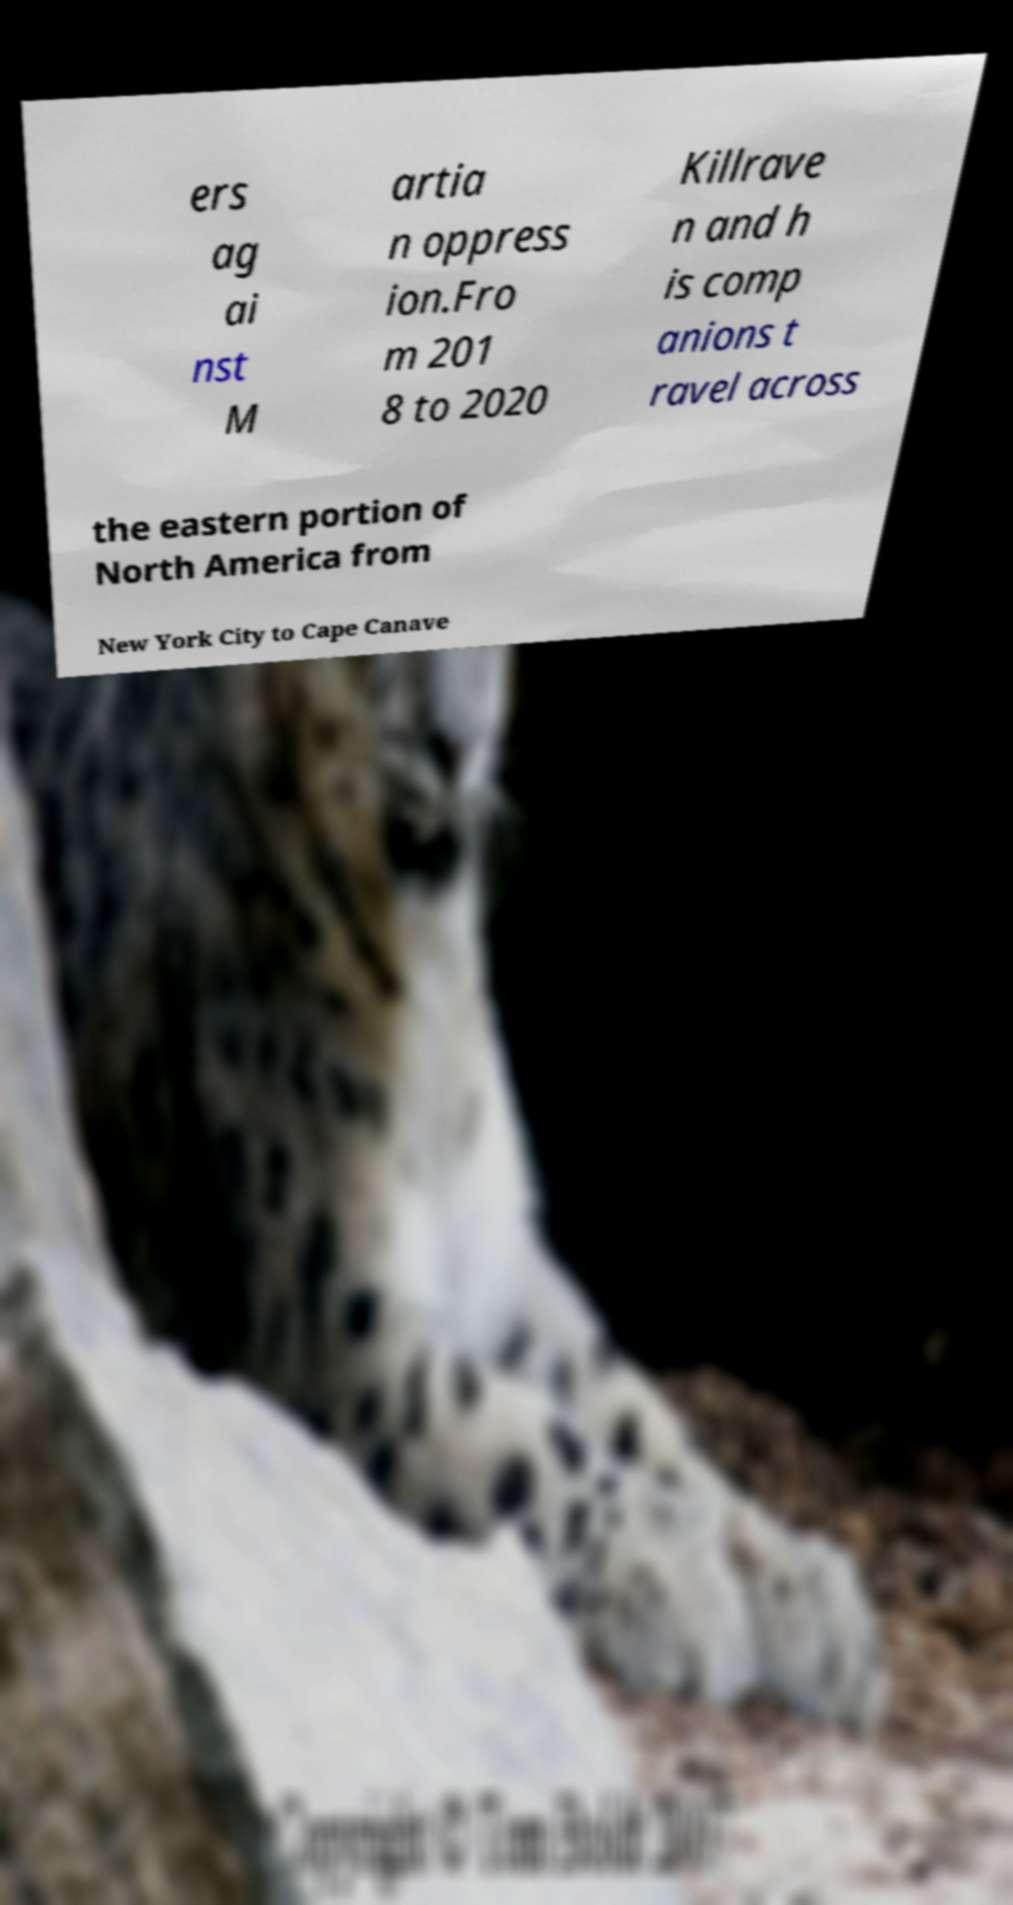Can you accurately transcribe the text from the provided image for me? ers ag ai nst M artia n oppress ion.Fro m 201 8 to 2020 Killrave n and h is comp anions t ravel across the eastern portion of North America from New York City to Cape Canave 